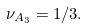<formula> <loc_0><loc_0><loc_500><loc_500>\nu _ { A _ { 3 } } = 1 / 3 .</formula> 